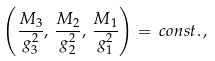Convert formula to latex. <formula><loc_0><loc_0><loc_500><loc_500>\left ( \frac { M _ { 3 } } { g _ { 3 } ^ { 2 } } , \, \frac { M _ { 2 } } { g _ { 2 } ^ { 2 } } , \, \frac { M _ { 1 } } { g _ { 1 } ^ { 2 } } \right ) = \, c o n s t . \, ,</formula> 